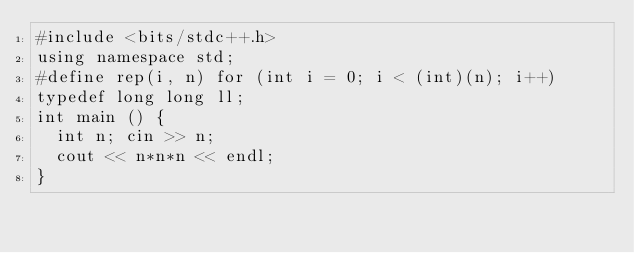Convert code to text. <code><loc_0><loc_0><loc_500><loc_500><_C++_>#include <bits/stdc++.h>
using namespace std;
#define rep(i, n) for (int i = 0; i < (int)(n); i++)
typedef long long ll;
int main () {
  int n; cin >> n;
  cout << n*n*n << endl;
}
</code> 